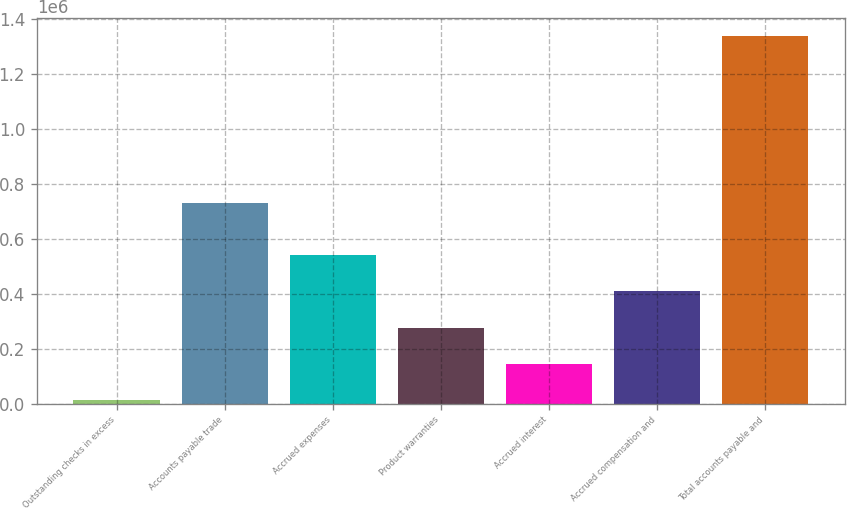<chart> <loc_0><loc_0><loc_500><loc_500><bar_chart><fcel>Outstanding checks in excess<fcel>Accounts payable trade<fcel>Accrued expenses<fcel>Product warranties<fcel>Accrued interest<fcel>Accrued compensation and<fcel>Total accounts payable and<nl><fcel>12269<fcel>729415<fcel>541594<fcel>276932<fcel>144600<fcel>409263<fcel>1.33558e+06<nl></chart> 